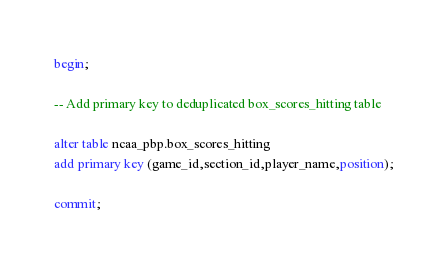Convert code to text. <code><loc_0><loc_0><loc_500><loc_500><_SQL_>begin;

-- Add primary key to deduplicated box_scores_hitting table

alter table ncaa_pbp.box_scores_hitting
add primary key (game_id,section_id,player_name,position);

commit;
</code> 